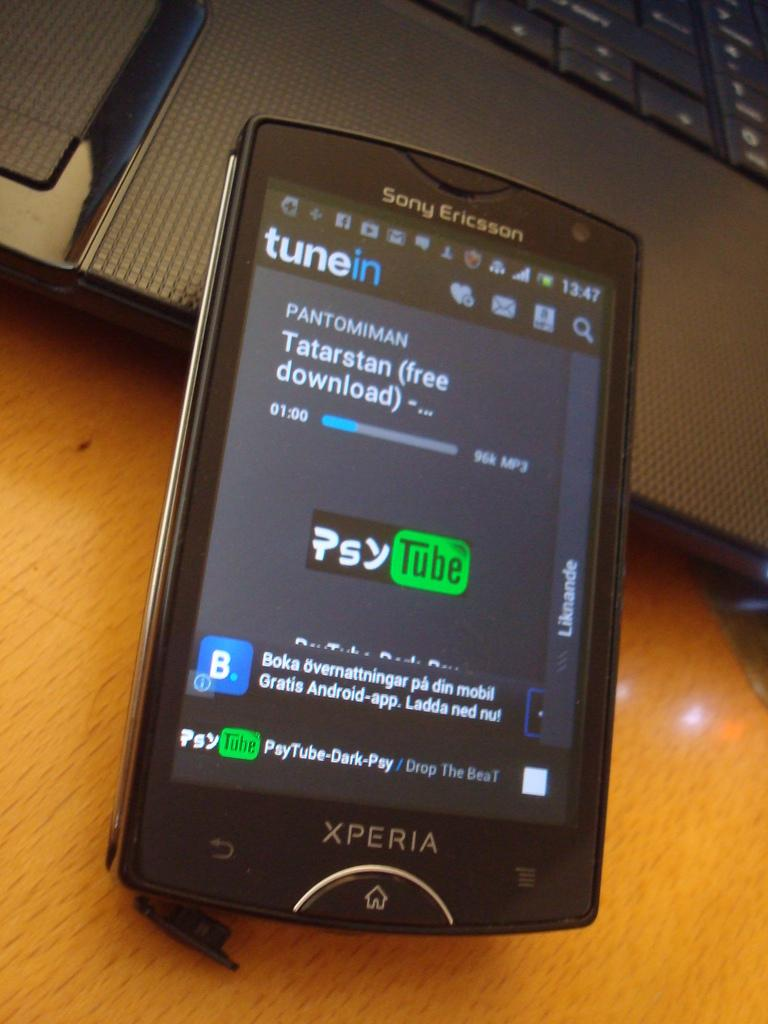<image>
Relay a brief, clear account of the picture shown. a sony ericsson phone with a psytube in black and green on the screen 